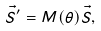Convert formula to latex. <formula><loc_0><loc_0><loc_500><loc_500>\vec { S } ^ { \prime } = M ( \theta ) \vec { S } ,</formula> 